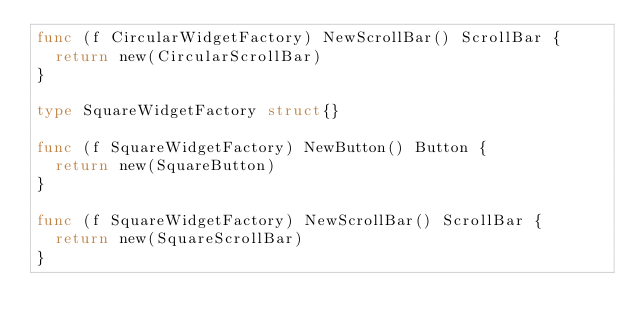<code> <loc_0><loc_0><loc_500><loc_500><_Go_>func (f CircularWidgetFactory) NewScrollBar() ScrollBar {
	return new(CircularScrollBar)
}

type SquareWidgetFactory struct{}

func (f SquareWidgetFactory) NewButton() Button {
	return new(SquareButton)
}

func (f SquareWidgetFactory) NewScrollBar() ScrollBar {
	return new(SquareScrollBar)
}
</code> 